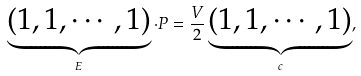<formula> <loc_0><loc_0><loc_500><loc_500>\underbrace { ( 1 , 1 , \cdots , 1 ) } _ { E } \cdot P = \frac { V } { 2 } \underbrace { ( 1 , 1 , \cdots , 1 ) } _ { c } ,</formula> 